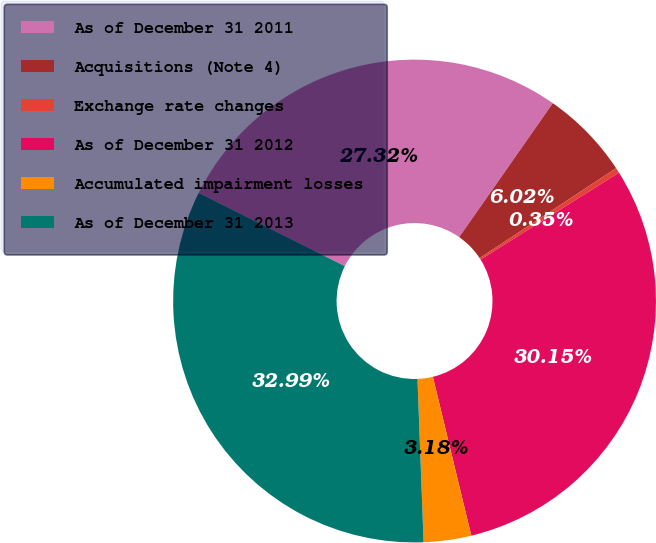Convert chart. <chart><loc_0><loc_0><loc_500><loc_500><pie_chart><fcel>As of December 31 2011<fcel>Acquisitions (Note 4)<fcel>Exchange rate changes<fcel>As of December 31 2012<fcel>Accumulated impairment losses<fcel>As of December 31 2013<nl><fcel>27.32%<fcel>6.02%<fcel>0.35%<fcel>30.15%<fcel>3.18%<fcel>32.99%<nl></chart> 